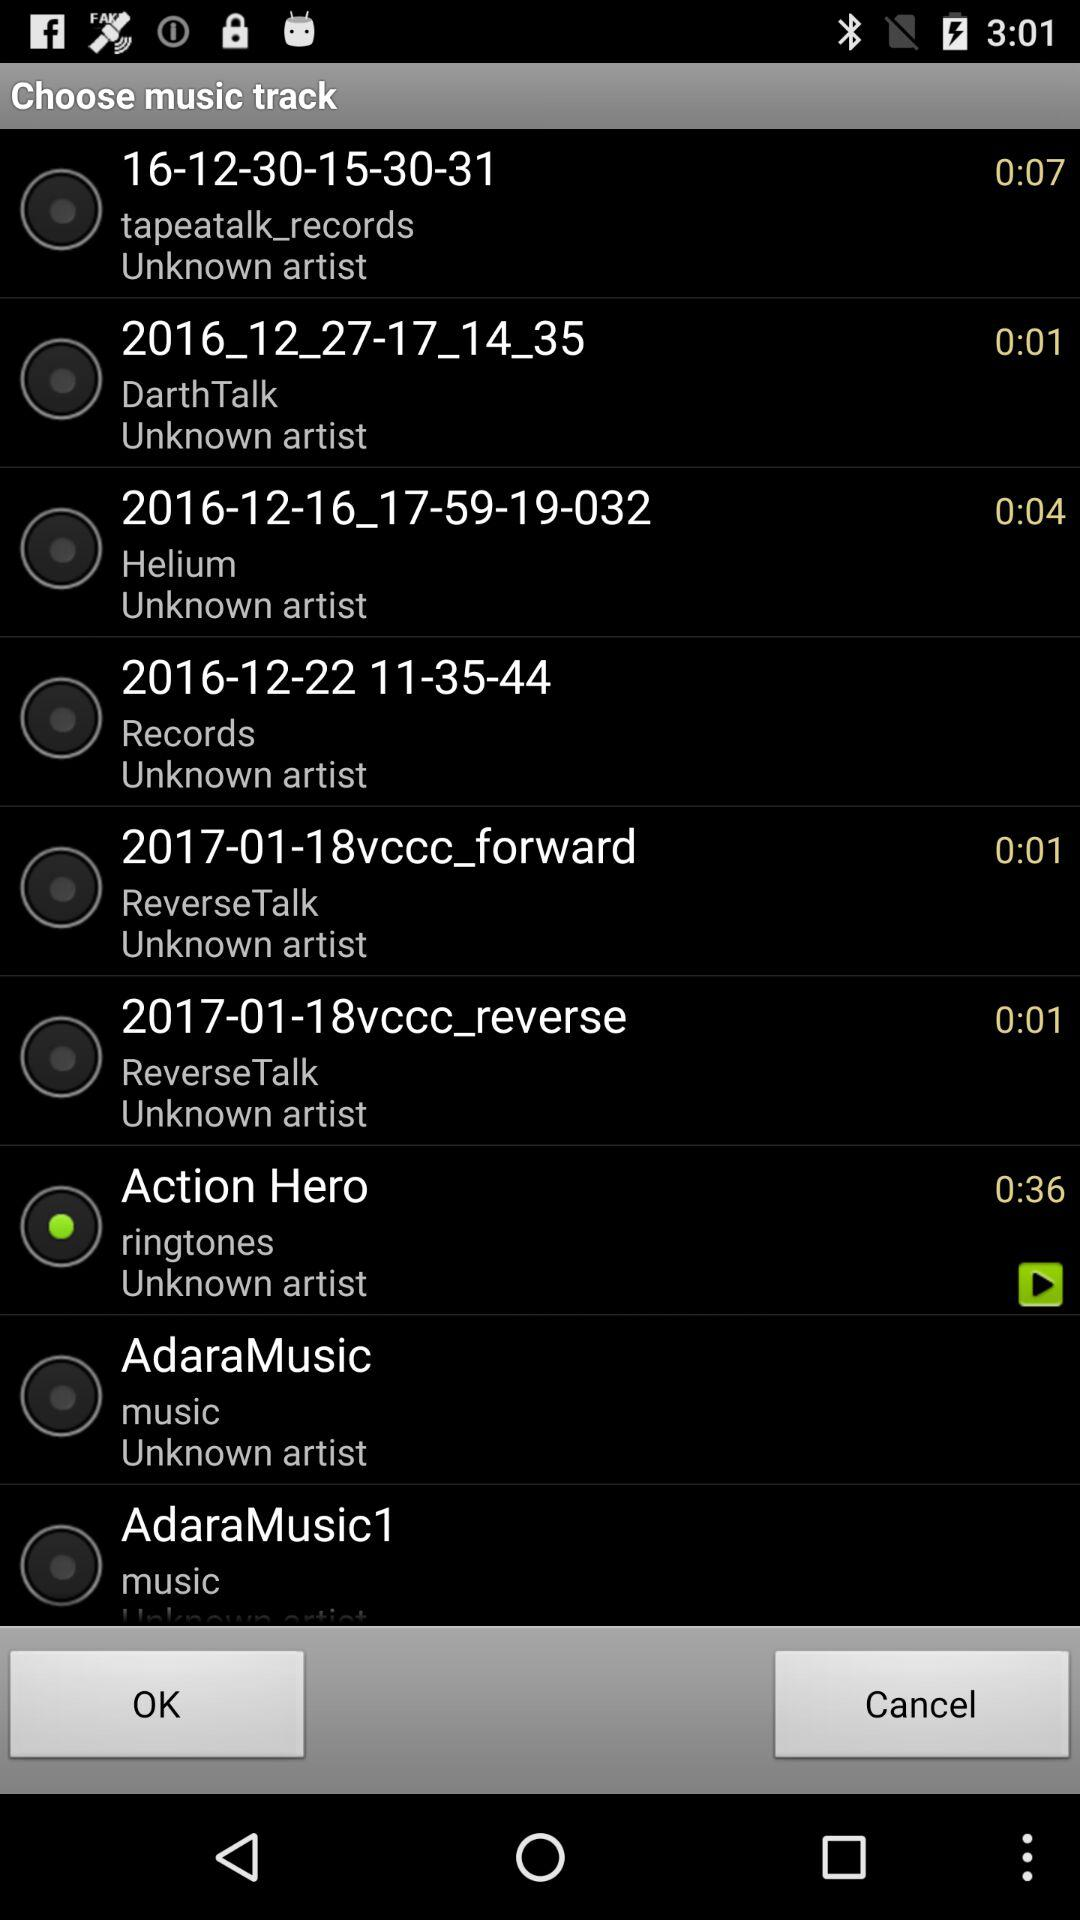What is the selected music track? The selected music track is "Action Hero". 